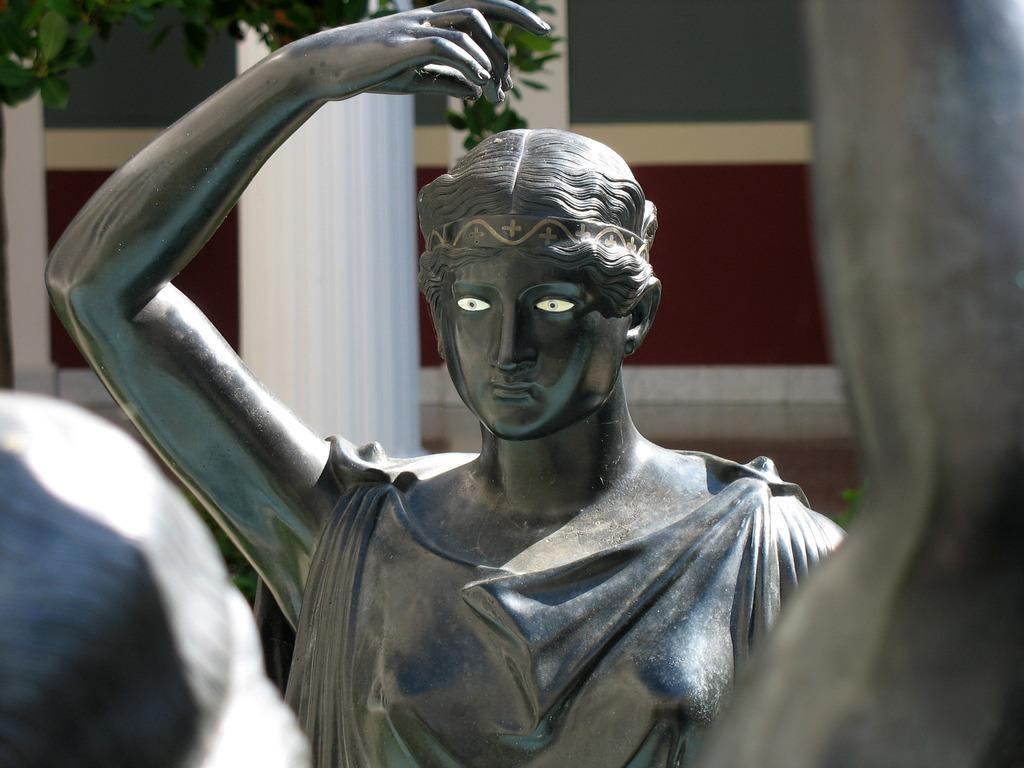What is the main subject in the image? There is a statue in the image. What is the color of the statue? The statue is grey in color. What other structures can be seen in the image? There is a white color pillar in the image. What type of vegetation is present in the image? There is a tree in the image. What is visible in the background of the image? There is a wall in the background of the image. Where is the toothpaste placed in the image? There is no toothpaste present in the image. What type of sand can be seen on the statue in the image? There is no sand present on the statue or in the image. 